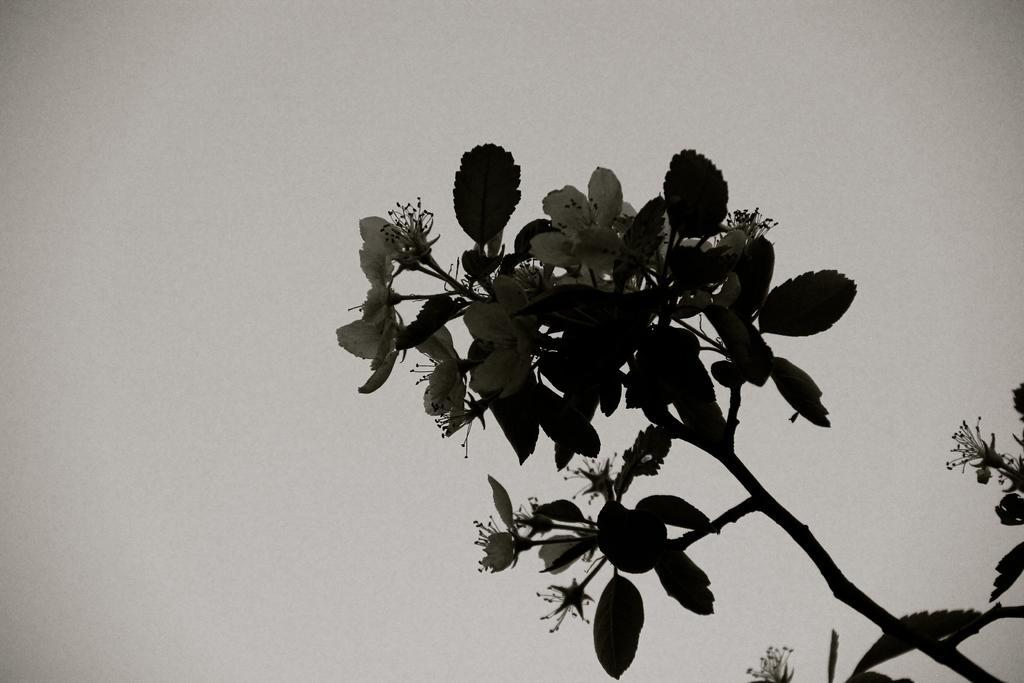Please provide a concise description of this image. In this image there are flowers, leaves and stem of a plant. In the background there is the sky. 